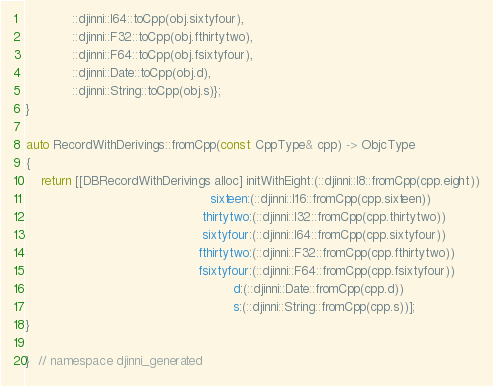<code> <loc_0><loc_0><loc_500><loc_500><_ObjectiveC_>            ::djinni::I64::toCpp(obj.sixtyfour),
            ::djinni::F32::toCpp(obj.fthirtytwo),
            ::djinni::F64::toCpp(obj.fsixtyfour),
            ::djinni::Date::toCpp(obj.d),
            ::djinni::String::toCpp(obj.s)};
}

auto RecordWithDerivings::fromCpp(const CppType& cpp) -> ObjcType
{
    return [[DBRecordWithDerivings alloc] initWithEight:(::djinni::I8::fromCpp(cpp.eight))
                                                sixteen:(::djinni::I16::fromCpp(cpp.sixteen))
                                              thirtytwo:(::djinni::I32::fromCpp(cpp.thirtytwo))
                                              sixtyfour:(::djinni::I64::fromCpp(cpp.sixtyfour))
                                             fthirtytwo:(::djinni::F32::fromCpp(cpp.fthirtytwo))
                                             fsixtyfour:(::djinni::F64::fromCpp(cpp.fsixtyfour))
                                                      d:(::djinni::Date::fromCpp(cpp.d))
                                                      s:(::djinni::String::fromCpp(cpp.s))];
}

}  // namespace djinni_generated
</code> 